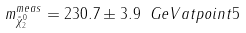<formula> <loc_0><loc_0><loc_500><loc_500>m _ { \tilde { \chi } _ { 2 } ^ { 0 } } ^ { m e a s } = 2 3 0 . 7 \pm 3 . 9 \ G e V a t p o i n t 5</formula> 